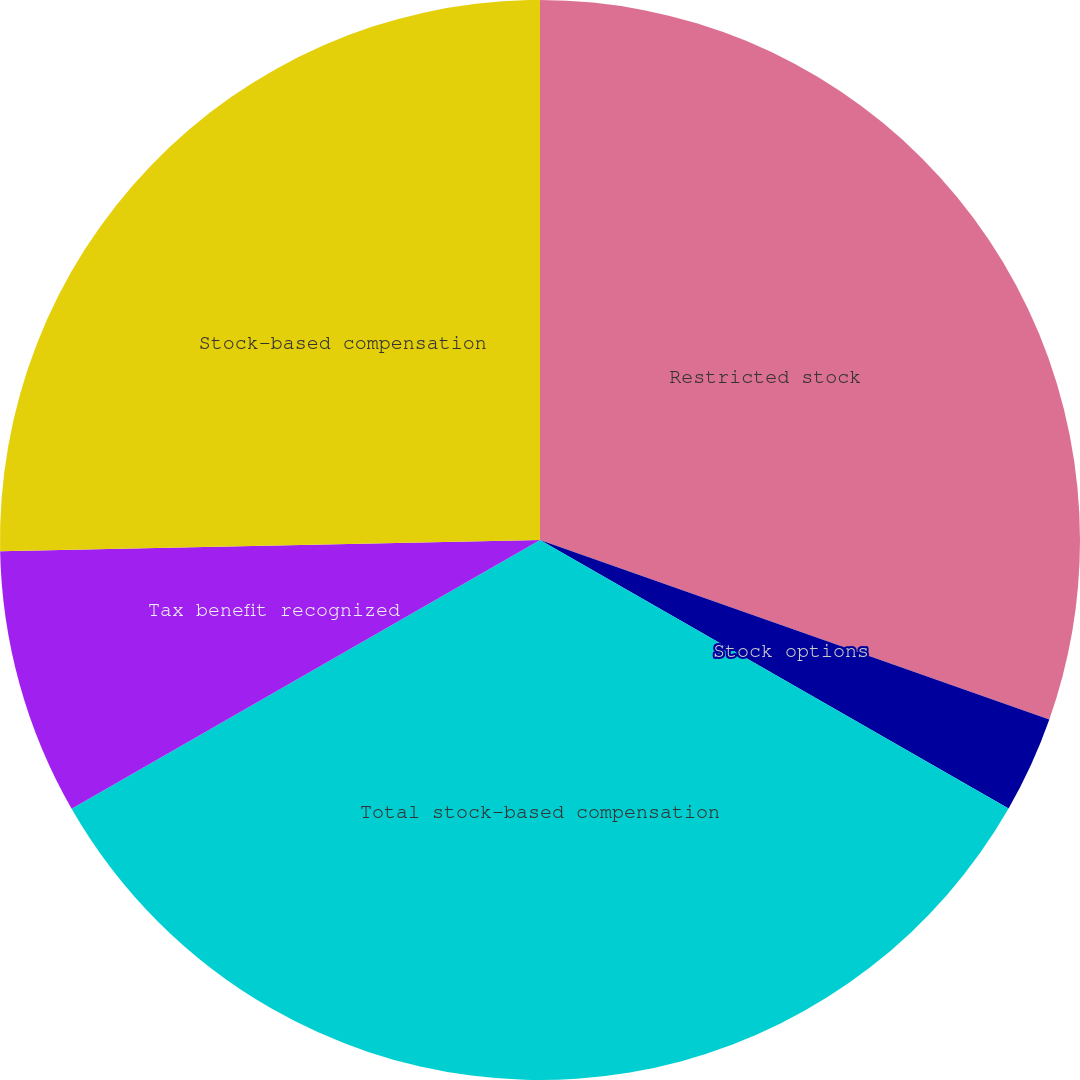Convert chart to OTSL. <chart><loc_0><loc_0><loc_500><loc_500><pie_chart><fcel>Restricted stock<fcel>Stock options<fcel>Total stock-based compensation<fcel>Tax benefit recognized<fcel>Stock-based compensation<nl><fcel>30.39%<fcel>2.89%<fcel>33.43%<fcel>7.96%<fcel>25.33%<nl></chart> 